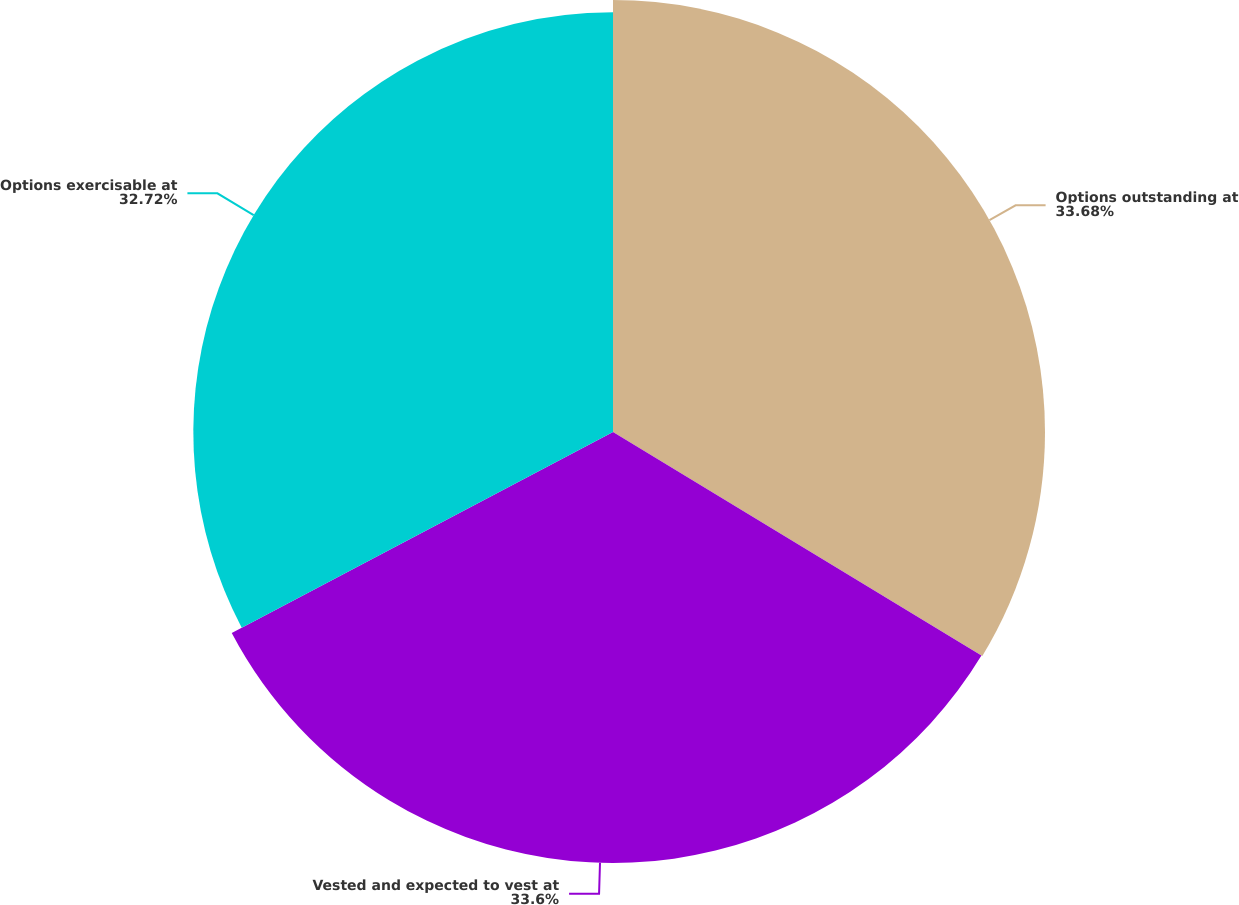Convert chart to OTSL. <chart><loc_0><loc_0><loc_500><loc_500><pie_chart><fcel>Options outstanding at<fcel>Vested and expected to vest at<fcel>Options exercisable at<nl><fcel>33.68%<fcel>33.6%<fcel>32.72%<nl></chart> 